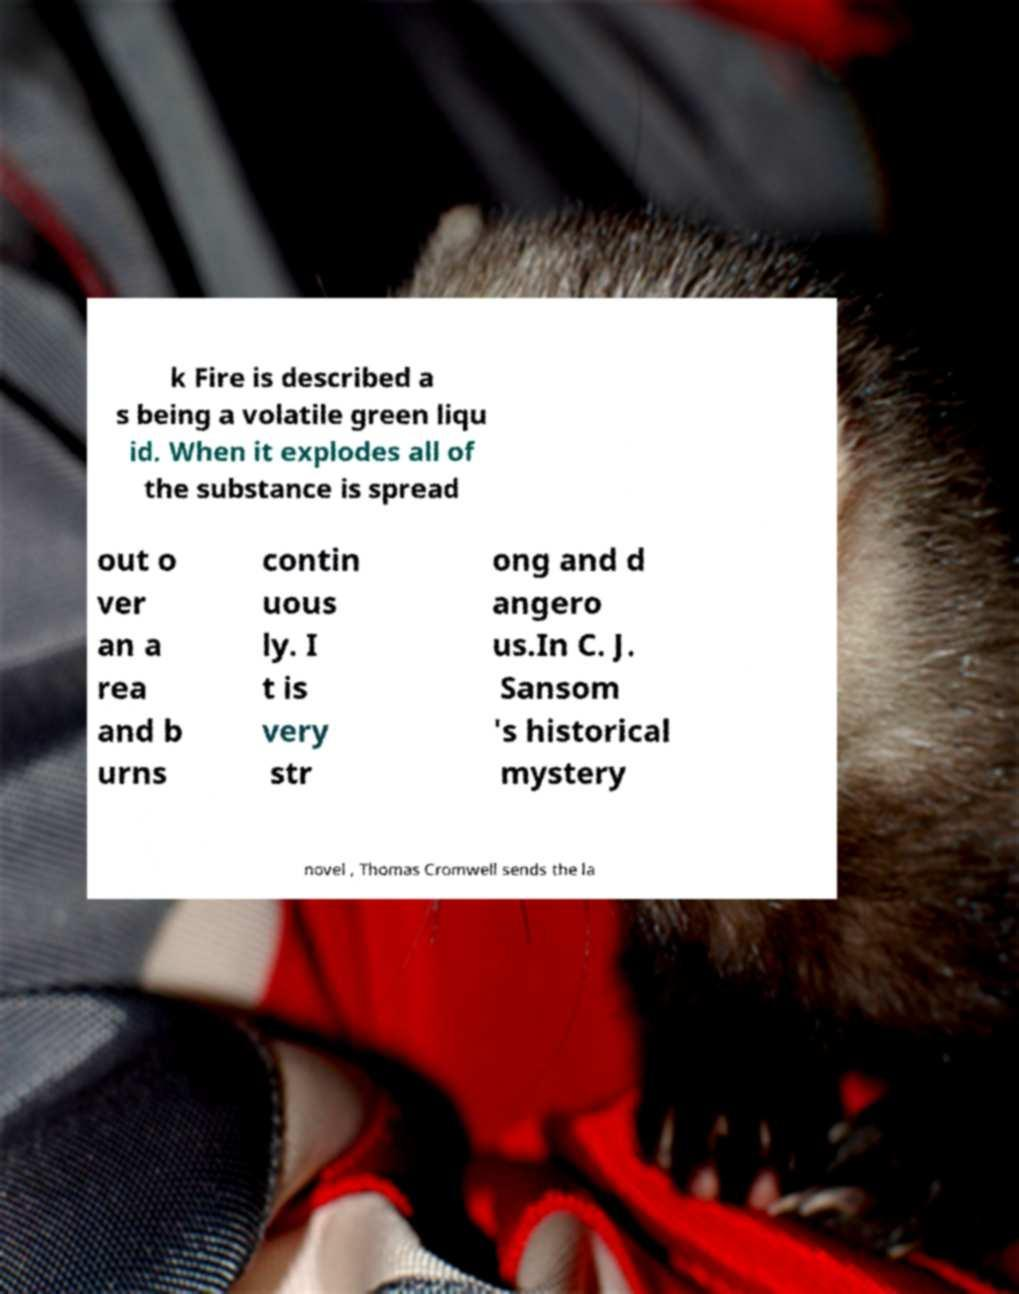I need the written content from this picture converted into text. Can you do that? k Fire is described a s being a volatile green liqu id. When it explodes all of the substance is spread out o ver an a rea and b urns contin uous ly. I t is very str ong and d angero us.In C. J. Sansom 's historical mystery novel , Thomas Cromwell sends the la 